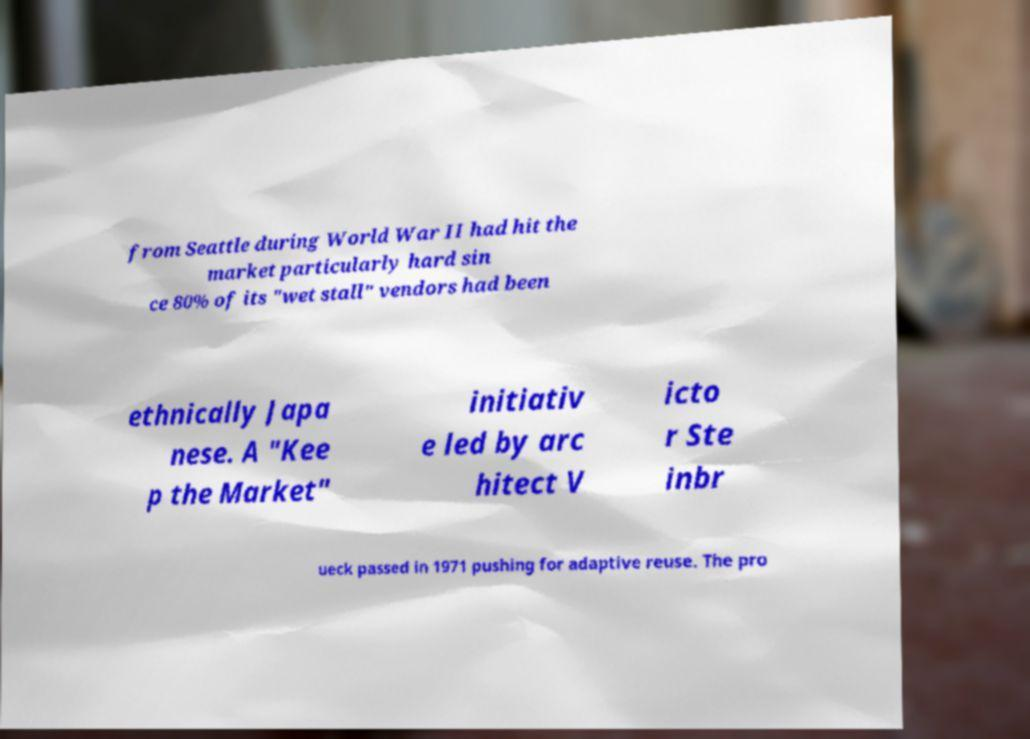What messages or text are displayed in this image? I need them in a readable, typed format. from Seattle during World War II had hit the market particularly hard sin ce 80% of its "wet stall" vendors had been ethnically Japa nese. A "Kee p the Market" initiativ e led by arc hitect V icto r Ste inbr ueck passed in 1971 pushing for adaptive reuse. The pro 